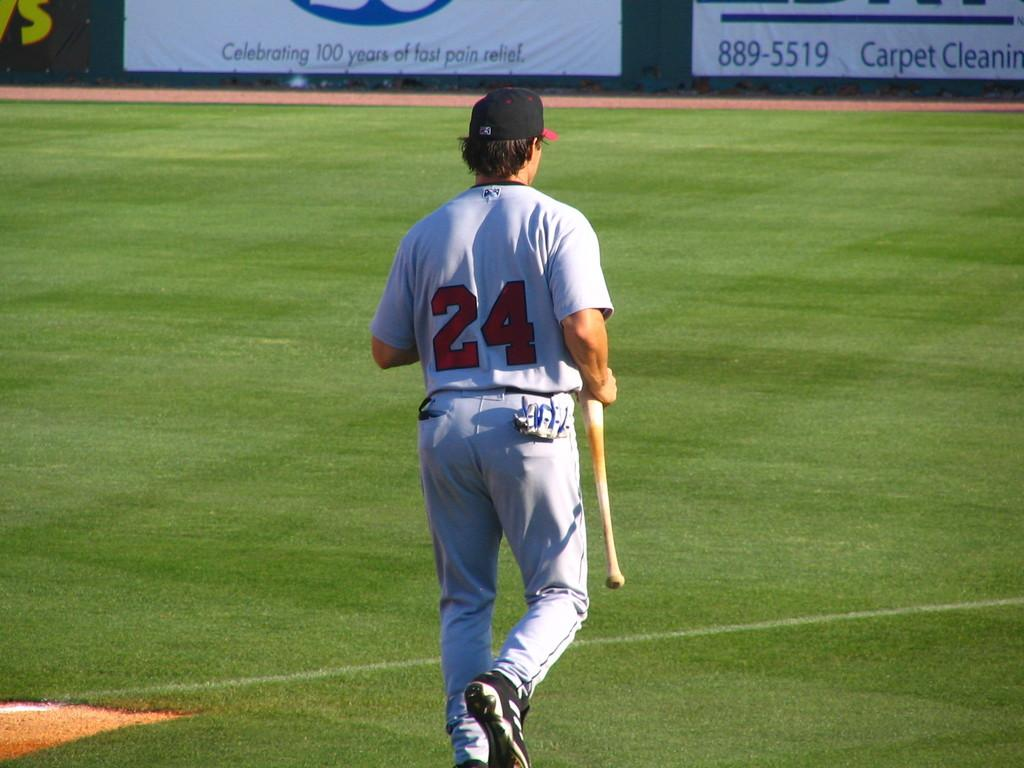<image>
Relay a brief, clear account of the picture shown. A baseball player is holding a bat and walking on the field by a sign that says Carpet Cleaning. 